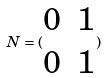Convert formula to latex. <formula><loc_0><loc_0><loc_500><loc_500>N = ( \begin{matrix} 0 & 1 \\ 0 & 1 \end{matrix} )</formula> 